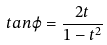Convert formula to latex. <formula><loc_0><loc_0><loc_500><loc_500>t a n \varphi = \frac { 2 t } { 1 - t ^ { 2 } }</formula> 